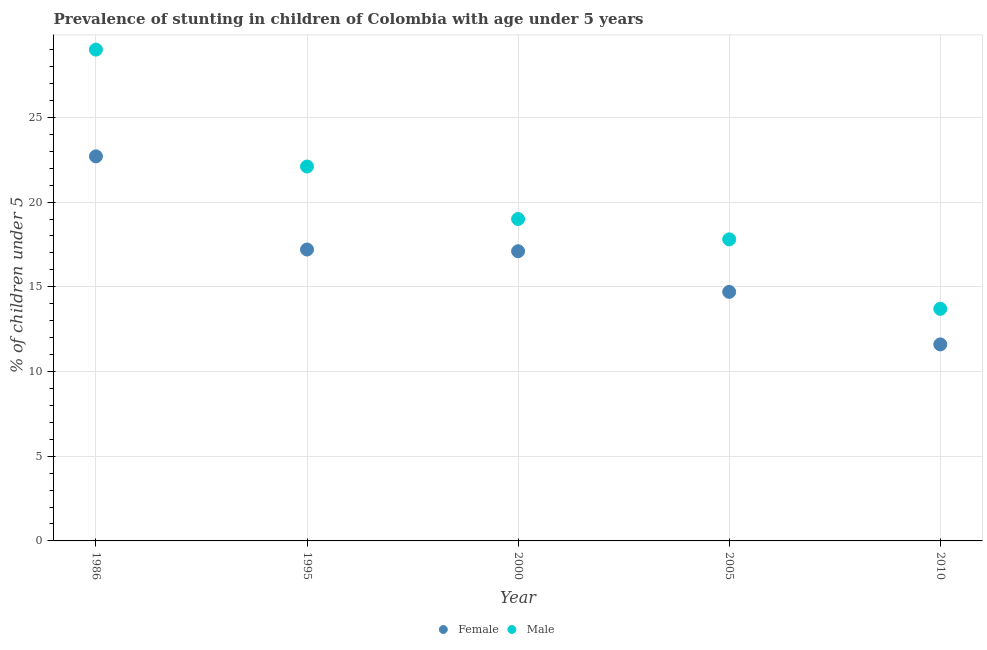How many different coloured dotlines are there?
Your answer should be compact. 2. What is the percentage of stunted female children in 1995?
Keep it short and to the point. 17.2. Across all years, what is the maximum percentage of stunted female children?
Provide a succinct answer. 22.7. Across all years, what is the minimum percentage of stunted female children?
Keep it short and to the point. 11.6. What is the total percentage of stunted female children in the graph?
Keep it short and to the point. 83.3. What is the difference between the percentage of stunted female children in 1995 and that in 2000?
Provide a succinct answer. 0.1. What is the difference between the percentage of stunted female children in 2000 and the percentage of stunted male children in 2005?
Provide a short and direct response. -0.7. What is the average percentage of stunted female children per year?
Your answer should be compact. 16.66. In the year 2005, what is the difference between the percentage of stunted female children and percentage of stunted male children?
Keep it short and to the point. -3.1. In how many years, is the percentage of stunted male children greater than 2 %?
Offer a terse response. 5. What is the ratio of the percentage of stunted male children in 1986 to that in 1995?
Keep it short and to the point. 1.31. Is the difference between the percentage of stunted male children in 1986 and 2005 greater than the difference between the percentage of stunted female children in 1986 and 2005?
Provide a short and direct response. Yes. What is the difference between the highest and the lowest percentage of stunted male children?
Give a very brief answer. 15.3. In how many years, is the percentage of stunted female children greater than the average percentage of stunted female children taken over all years?
Your answer should be compact. 3. Is the sum of the percentage of stunted male children in 1986 and 2000 greater than the maximum percentage of stunted female children across all years?
Ensure brevity in your answer.  Yes. Does the percentage of stunted male children monotonically increase over the years?
Ensure brevity in your answer.  No. Is the percentage of stunted female children strictly greater than the percentage of stunted male children over the years?
Provide a short and direct response. No. Is the percentage of stunted male children strictly less than the percentage of stunted female children over the years?
Keep it short and to the point. No. What is the title of the graph?
Give a very brief answer. Prevalence of stunting in children of Colombia with age under 5 years. Does "Goods and services" appear as one of the legend labels in the graph?
Your answer should be compact. No. What is the label or title of the X-axis?
Your response must be concise. Year. What is the label or title of the Y-axis?
Make the answer very short.  % of children under 5. What is the  % of children under 5 of Female in 1986?
Your answer should be very brief. 22.7. What is the  % of children under 5 in Female in 1995?
Provide a succinct answer. 17.2. What is the  % of children under 5 in Male in 1995?
Your answer should be very brief. 22.1. What is the  % of children under 5 in Female in 2000?
Offer a terse response. 17.1. What is the  % of children under 5 in Male in 2000?
Your answer should be compact. 19. What is the  % of children under 5 in Female in 2005?
Offer a very short reply. 14.7. What is the  % of children under 5 of Male in 2005?
Provide a short and direct response. 17.8. What is the  % of children under 5 in Female in 2010?
Ensure brevity in your answer.  11.6. What is the  % of children under 5 in Male in 2010?
Offer a very short reply. 13.7. Across all years, what is the maximum  % of children under 5 in Female?
Offer a very short reply. 22.7. Across all years, what is the minimum  % of children under 5 of Female?
Your answer should be very brief. 11.6. Across all years, what is the minimum  % of children under 5 in Male?
Your response must be concise. 13.7. What is the total  % of children under 5 in Female in the graph?
Your answer should be compact. 83.3. What is the total  % of children under 5 of Male in the graph?
Make the answer very short. 101.6. What is the difference between the  % of children under 5 of Male in 1986 and that in 1995?
Offer a terse response. 6.9. What is the difference between the  % of children under 5 of Male in 1986 and that in 2000?
Keep it short and to the point. 10. What is the difference between the  % of children under 5 of Female in 1986 and that in 2005?
Your response must be concise. 8. What is the difference between the  % of children under 5 of Male in 1986 and that in 2005?
Your answer should be compact. 11.2. What is the difference between the  % of children under 5 of Female in 1986 and that in 2010?
Your answer should be compact. 11.1. What is the difference between the  % of children under 5 in Female in 1995 and that in 2000?
Offer a terse response. 0.1. What is the difference between the  % of children under 5 of Male in 1995 and that in 2000?
Offer a terse response. 3.1. What is the difference between the  % of children under 5 in Female in 1995 and that in 2005?
Provide a short and direct response. 2.5. What is the difference between the  % of children under 5 of Male in 1995 and that in 2010?
Your answer should be compact. 8.4. What is the difference between the  % of children under 5 in Female in 2000 and that in 2005?
Offer a terse response. 2.4. What is the difference between the  % of children under 5 of Male in 2000 and that in 2005?
Provide a succinct answer. 1.2. What is the difference between the  % of children under 5 in Male in 2000 and that in 2010?
Give a very brief answer. 5.3. What is the difference between the  % of children under 5 in Male in 2005 and that in 2010?
Your answer should be compact. 4.1. What is the difference between the  % of children under 5 of Female in 1986 and the  % of children under 5 of Male in 2000?
Provide a succinct answer. 3.7. What is the difference between the  % of children under 5 in Female in 1986 and the  % of children under 5 in Male in 2005?
Provide a short and direct response. 4.9. What is the difference between the  % of children under 5 in Female in 1995 and the  % of children under 5 in Male in 2010?
Make the answer very short. 3.5. What is the difference between the  % of children under 5 in Female in 2005 and the  % of children under 5 in Male in 2010?
Keep it short and to the point. 1. What is the average  % of children under 5 in Female per year?
Provide a succinct answer. 16.66. What is the average  % of children under 5 of Male per year?
Your answer should be very brief. 20.32. In the year 1986, what is the difference between the  % of children under 5 of Female and  % of children under 5 of Male?
Your answer should be very brief. -6.3. In the year 1995, what is the difference between the  % of children under 5 in Female and  % of children under 5 in Male?
Keep it short and to the point. -4.9. In the year 2000, what is the difference between the  % of children under 5 in Female and  % of children under 5 in Male?
Offer a very short reply. -1.9. In the year 2005, what is the difference between the  % of children under 5 of Female and  % of children under 5 of Male?
Make the answer very short. -3.1. What is the ratio of the  % of children under 5 of Female in 1986 to that in 1995?
Provide a short and direct response. 1.32. What is the ratio of the  % of children under 5 of Male in 1986 to that in 1995?
Offer a very short reply. 1.31. What is the ratio of the  % of children under 5 in Female in 1986 to that in 2000?
Make the answer very short. 1.33. What is the ratio of the  % of children under 5 in Male in 1986 to that in 2000?
Your answer should be compact. 1.53. What is the ratio of the  % of children under 5 of Female in 1986 to that in 2005?
Your response must be concise. 1.54. What is the ratio of the  % of children under 5 in Male in 1986 to that in 2005?
Your response must be concise. 1.63. What is the ratio of the  % of children under 5 in Female in 1986 to that in 2010?
Provide a succinct answer. 1.96. What is the ratio of the  % of children under 5 in Male in 1986 to that in 2010?
Your response must be concise. 2.12. What is the ratio of the  % of children under 5 of Female in 1995 to that in 2000?
Give a very brief answer. 1.01. What is the ratio of the  % of children under 5 in Male in 1995 to that in 2000?
Offer a very short reply. 1.16. What is the ratio of the  % of children under 5 of Female in 1995 to that in 2005?
Your answer should be very brief. 1.17. What is the ratio of the  % of children under 5 of Male in 1995 to that in 2005?
Keep it short and to the point. 1.24. What is the ratio of the  % of children under 5 in Female in 1995 to that in 2010?
Provide a succinct answer. 1.48. What is the ratio of the  % of children under 5 in Male in 1995 to that in 2010?
Offer a very short reply. 1.61. What is the ratio of the  % of children under 5 in Female in 2000 to that in 2005?
Your answer should be compact. 1.16. What is the ratio of the  % of children under 5 of Male in 2000 to that in 2005?
Ensure brevity in your answer.  1.07. What is the ratio of the  % of children under 5 in Female in 2000 to that in 2010?
Your answer should be very brief. 1.47. What is the ratio of the  % of children under 5 in Male in 2000 to that in 2010?
Provide a succinct answer. 1.39. What is the ratio of the  % of children under 5 in Female in 2005 to that in 2010?
Provide a short and direct response. 1.27. What is the ratio of the  % of children under 5 in Male in 2005 to that in 2010?
Ensure brevity in your answer.  1.3. What is the difference between the highest and the second highest  % of children under 5 in Male?
Give a very brief answer. 6.9. 